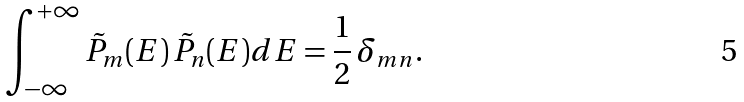<formula> <loc_0><loc_0><loc_500><loc_500>\int _ { - \infty } ^ { + \infty } \tilde { P } _ { m } ( E ) \, \tilde { P } _ { n } ( E ) d E = \frac { 1 } { 2 } \, \delta _ { m n } .</formula> 